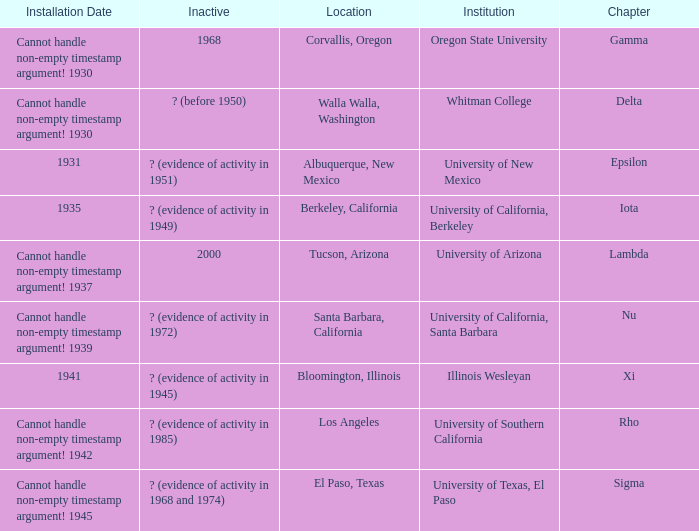What is the installation date for the Delta Chapter? Cannot handle non-empty timestamp argument! 1930. 